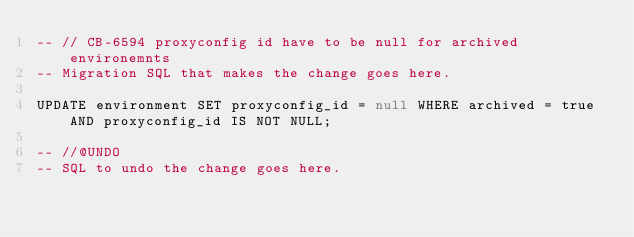Convert code to text. <code><loc_0><loc_0><loc_500><loc_500><_SQL_>-- // CB-6594 proxyconfig id have to be null for archived environemnts
-- Migration SQL that makes the change goes here.

UPDATE environment SET proxyconfig_id = null WHERE archived = true AND proxyconfig_id IS NOT NULL;

-- //@UNDO
-- SQL to undo the change goes here.
</code> 